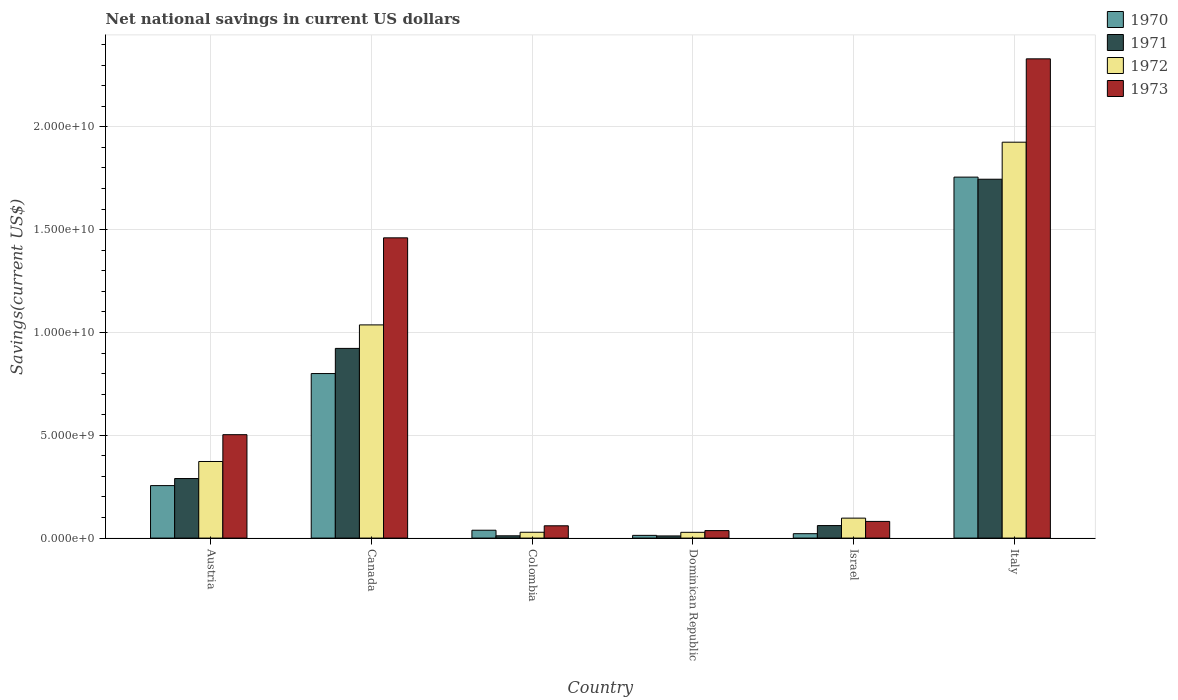Are the number of bars per tick equal to the number of legend labels?
Keep it short and to the point. Yes. How many bars are there on the 5th tick from the left?
Offer a terse response. 4. How many bars are there on the 3rd tick from the right?
Your answer should be compact. 4. What is the net national savings in 1973 in Israel?
Keep it short and to the point. 8.11e+08. Across all countries, what is the maximum net national savings in 1970?
Your answer should be compact. 1.76e+1. Across all countries, what is the minimum net national savings in 1970?
Offer a very short reply. 1.33e+08. In which country was the net national savings in 1971 minimum?
Provide a short and direct response. Dominican Republic. What is the total net national savings in 1972 in the graph?
Your answer should be very brief. 3.49e+1. What is the difference between the net national savings in 1970 in Austria and that in Italy?
Ensure brevity in your answer.  -1.50e+1. What is the difference between the net national savings in 1973 in Canada and the net national savings in 1970 in Dominican Republic?
Your answer should be very brief. 1.45e+1. What is the average net national savings in 1973 per country?
Your response must be concise. 7.45e+09. What is the difference between the net national savings of/in 1972 and net national savings of/in 1973 in Colombia?
Provide a short and direct response. -3.14e+08. In how many countries, is the net national savings in 1971 greater than 22000000000 US$?
Provide a succinct answer. 0. What is the ratio of the net national savings in 1972 in Israel to that in Italy?
Your answer should be very brief. 0.05. Is the net national savings in 1971 in Canada less than that in Dominican Republic?
Make the answer very short. No. Is the difference between the net national savings in 1972 in Colombia and Israel greater than the difference between the net national savings in 1973 in Colombia and Israel?
Offer a very short reply. No. What is the difference between the highest and the second highest net national savings in 1972?
Offer a terse response. 8.89e+09. What is the difference between the highest and the lowest net national savings in 1973?
Your response must be concise. 2.29e+1. In how many countries, is the net national savings in 1971 greater than the average net national savings in 1971 taken over all countries?
Your answer should be very brief. 2. Is it the case that in every country, the sum of the net national savings in 1971 and net national savings in 1973 is greater than the sum of net national savings in 1972 and net national savings in 1970?
Give a very brief answer. No. Is it the case that in every country, the sum of the net national savings in 1972 and net national savings in 1971 is greater than the net national savings in 1970?
Give a very brief answer. Yes. How many bars are there?
Offer a terse response. 24. Are all the bars in the graph horizontal?
Make the answer very short. No. Does the graph contain grids?
Ensure brevity in your answer.  Yes. How are the legend labels stacked?
Make the answer very short. Vertical. What is the title of the graph?
Your response must be concise. Net national savings in current US dollars. Does "2014" appear as one of the legend labels in the graph?
Provide a short and direct response. No. What is the label or title of the X-axis?
Offer a very short reply. Country. What is the label or title of the Y-axis?
Your response must be concise. Savings(current US$). What is the Savings(current US$) of 1970 in Austria?
Keep it short and to the point. 2.55e+09. What is the Savings(current US$) of 1971 in Austria?
Keep it short and to the point. 2.90e+09. What is the Savings(current US$) of 1972 in Austria?
Provide a short and direct response. 3.73e+09. What is the Savings(current US$) of 1973 in Austria?
Keep it short and to the point. 5.03e+09. What is the Savings(current US$) of 1970 in Canada?
Provide a succinct answer. 8.00e+09. What is the Savings(current US$) of 1971 in Canada?
Ensure brevity in your answer.  9.23e+09. What is the Savings(current US$) in 1972 in Canada?
Give a very brief answer. 1.04e+1. What is the Savings(current US$) in 1973 in Canada?
Provide a succinct answer. 1.46e+1. What is the Savings(current US$) of 1970 in Colombia?
Ensure brevity in your answer.  3.83e+08. What is the Savings(current US$) of 1971 in Colombia?
Your answer should be compact. 1.11e+08. What is the Savings(current US$) of 1972 in Colombia?
Your response must be concise. 2.84e+08. What is the Savings(current US$) in 1973 in Colombia?
Give a very brief answer. 5.98e+08. What is the Savings(current US$) of 1970 in Dominican Republic?
Your response must be concise. 1.33e+08. What is the Savings(current US$) of 1971 in Dominican Republic?
Offer a very short reply. 1.05e+08. What is the Savings(current US$) in 1972 in Dominican Republic?
Ensure brevity in your answer.  2.80e+08. What is the Savings(current US$) of 1973 in Dominican Republic?
Make the answer very short. 3.65e+08. What is the Savings(current US$) of 1970 in Israel?
Your response must be concise. 2.15e+08. What is the Savings(current US$) in 1971 in Israel?
Provide a short and direct response. 6.09e+08. What is the Savings(current US$) in 1972 in Israel?
Offer a very short reply. 9.71e+08. What is the Savings(current US$) in 1973 in Israel?
Give a very brief answer. 8.11e+08. What is the Savings(current US$) of 1970 in Italy?
Give a very brief answer. 1.76e+1. What is the Savings(current US$) of 1971 in Italy?
Keep it short and to the point. 1.75e+1. What is the Savings(current US$) in 1972 in Italy?
Your response must be concise. 1.93e+1. What is the Savings(current US$) in 1973 in Italy?
Make the answer very short. 2.33e+1. Across all countries, what is the maximum Savings(current US$) in 1970?
Provide a succinct answer. 1.76e+1. Across all countries, what is the maximum Savings(current US$) in 1971?
Offer a very short reply. 1.75e+1. Across all countries, what is the maximum Savings(current US$) in 1972?
Your response must be concise. 1.93e+1. Across all countries, what is the maximum Savings(current US$) of 1973?
Your response must be concise. 2.33e+1. Across all countries, what is the minimum Savings(current US$) of 1970?
Ensure brevity in your answer.  1.33e+08. Across all countries, what is the minimum Savings(current US$) in 1971?
Offer a terse response. 1.05e+08. Across all countries, what is the minimum Savings(current US$) in 1972?
Offer a very short reply. 2.80e+08. Across all countries, what is the minimum Savings(current US$) of 1973?
Offer a terse response. 3.65e+08. What is the total Savings(current US$) in 1970 in the graph?
Provide a short and direct response. 2.88e+1. What is the total Savings(current US$) of 1971 in the graph?
Offer a terse response. 3.04e+1. What is the total Savings(current US$) of 1972 in the graph?
Offer a very short reply. 3.49e+1. What is the total Savings(current US$) in 1973 in the graph?
Offer a very short reply. 4.47e+1. What is the difference between the Savings(current US$) of 1970 in Austria and that in Canada?
Provide a succinct answer. -5.45e+09. What is the difference between the Savings(current US$) in 1971 in Austria and that in Canada?
Your answer should be compact. -6.33e+09. What is the difference between the Savings(current US$) of 1972 in Austria and that in Canada?
Your answer should be compact. -6.64e+09. What is the difference between the Savings(current US$) in 1973 in Austria and that in Canada?
Your answer should be very brief. -9.57e+09. What is the difference between the Savings(current US$) in 1970 in Austria and that in Colombia?
Keep it short and to the point. 2.17e+09. What is the difference between the Savings(current US$) of 1971 in Austria and that in Colombia?
Make the answer very short. 2.78e+09. What is the difference between the Savings(current US$) of 1972 in Austria and that in Colombia?
Keep it short and to the point. 3.44e+09. What is the difference between the Savings(current US$) in 1973 in Austria and that in Colombia?
Offer a very short reply. 4.43e+09. What is the difference between the Savings(current US$) of 1970 in Austria and that in Dominican Republic?
Offer a very short reply. 2.42e+09. What is the difference between the Savings(current US$) of 1971 in Austria and that in Dominican Republic?
Provide a short and direct response. 2.79e+09. What is the difference between the Savings(current US$) of 1972 in Austria and that in Dominican Republic?
Make the answer very short. 3.44e+09. What is the difference between the Savings(current US$) in 1973 in Austria and that in Dominican Republic?
Make the answer very short. 4.66e+09. What is the difference between the Savings(current US$) of 1970 in Austria and that in Israel?
Your answer should be very brief. 2.34e+09. What is the difference between the Savings(current US$) in 1971 in Austria and that in Israel?
Make the answer very short. 2.29e+09. What is the difference between the Savings(current US$) of 1972 in Austria and that in Israel?
Ensure brevity in your answer.  2.75e+09. What is the difference between the Savings(current US$) in 1973 in Austria and that in Israel?
Make the answer very short. 4.22e+09. What is the difference between the Savings(current US$) of 1970 in Austria and that in Italy?
Your response must be concise. -1.50e+1. What is the difference between the Savings(current US$) of 1971 in Austria and that in Italy?
Keep it short and to the point. -1.46e+1. What is the difference between the Savings(current US$) of 1972 in Austria and that in Italy?
Ensure brevity in your answer.  -1.55e+1. What is the difference between the Savings(current US$) of 1973 in Austria and that in Italy?
Make the answer very short. -1.83e+1. What is the difference between the Savings(current US$) in 1970 in Canada and that in Colombia?
Offer a terse response. 7.62e+09. What is the difference between the Savings(current US$) of 1971 in Canada and that in Colombia?
Your answer should be compact. 9.11e+09. What is the difference between the Savings(current US$) of 1972 in Canada and that in Colombia?
Keep it short and to the point. 1.01e+1. What is the difference between the Savings(current US$) in 1973 in Canada and that in Colombia?
Give a very brief answer. 1.40e+1. What is the difference between the Savings(current US$) of 1970 in Canada and that in Dominican Republic?
Ensure brevity in your answer.  7.87e+09. What is the difference between the Savings(current US$) in 1971 in Canada and that in Dominican Republic?
Make the answer very short. 9.12e+09. What is the difference between the Savings(current US$) in 1972 in Canada and that in Dominican Republic?
Your answer should be compact. 1.01e+1. What is the difference between the Savings(current US$) of 1973 in Canada and that in Dominican Republic?
Provide a succinct answer. 1.42e+1. What is the difference between the Savings(current US$) of 1970 in Canada and that in Israel?
Keep it short and to the point. 7.79e+09. What is the difference between the Savings(current US$) in 1971 in Canada and that in Israel?
Offer a very short reply. 8.62e+09. What is the difference between the Savings(current US$) of 1972 in Canada and that in Israel?
Give a very brief answer. 9.40e+09. What is the difference between the Savings(current US$) of 1973 in Canada and that in Israel?
Give a very brief answer. 1.38e+1. What is the difference between the Savings(current US$) of 1970 in Canada and that in Italy?
Offer a very short reply. -9.55e+09. What is the difference between the Savings(current US$) of 1971 in Canada and that in Italy?
Provide a short and direct response. -8.23e+09. What is the difference between the Savings(current US$) in 1972 in Canada and that in Italy?
Provide a short and direct response. -8.89e+09. What is the difference between the Savings(current US$) of 1973 in Canada and that in Italy?
Make the answer very short. -8.71e+09. What is the difference between the Savings(current US$) of 1970 in Colombia and that in Dominican Republic?
Make the answer very short. 2.50e+08. What is the difference between the Savings(current US$) of 1971 in Colombia and that in Dominican Republic?
Keep it short and to the point. 6.03e+06. What is the difference between the Savings(current US$) in 1972 in Colombia and that in Dominican Republic?
Offer a very short reply. 3.48e+06. What is the difference between the Savings(current US$) of 1973 in Colombia and that in Dominican Republic?
Give a very brief answer. 2.34e+08. What is the difference between the Savings(current US$) of 1970 in Colombia and that in Israel?
Make the answer very short. 1.68e+08. What is the difference between the Savings(current US$) in 1971 in Colombia and that in Israel?
Make the answer very short. -4.97e+08. What is the difference between the Savings(current US$) in 1972 in Colombia and that in Israel?
Ensure brevity in your answer.  -6.87e+08. What is the difference between the Savings(current US$) in 1973 in Colombia and that in Israel?
Provide a short and direct response. -2.12e+08. What is the difference between the Savings(current US$) in 1970 in Colombia and that in Italy?
Offer a very short reply. -1.72e+1. What is the difference between the Savings(current US$) in 1971 in Colombia and that in Italy?
Your answer should be compact. -1.73e+1. What is the difference between the Savings(current US$) of 1972 in Colombia and that in Italy?
Provide a succinct answer. -1.90e+1. What is the difference between the Savings(current US$) in 1973 in Colombia and that in Italy?
Give a very brief answer. -2.27e+1. What is the difference between the Savings(current US$) in 1970 in Dominican Republic and that in Israel?
Provide a short and direct response. -8.19e+07. What is the difference between the Savings(current US$) in 1971 in Dominican Republic and that in Israel?
Ensure brevity in your answer.  -5.03e+08. What is the difference between the Savings(current US$) in 1972 in Dominican Republic and that in Israel?
Provide a succinct answer. -6.90e+08. What is the difference between the Savings(current US$) of 1973 in Dominican Republic and that in Israel?
Provide a succinct answer. -4.46e+08. What is the difference between the Savings(current US$) in 1970 in Dominican Republic and that in Italy?
Provide a short and direct response. -1.74e+1. What is the difference between the Savings(current US$) of 1971 in Dominican Republic and that in Italy?
Your answer should be very brief. -1.73e+1. What is the difference between the Savings(current US$) in 1972 in Dominican Republic and that in Italy?
Keep it short and to the point. -1.90e+1. What is the difference between the Savings(current US$) of 1973 in Dominican Republic and that in Italy?
Keep it short and to the point. -2.29e+1. What is the difference between the Savings(current US$) of 1970 in Israel and that in Italy?
Provide a short and direct response. -1.73e+1. What is the difference between the Savings(current US$) of 1971 in Israel and that in Italy?
Your answer should be compact. -1.68e+1. What is the difference between the Savings(current US$) of 1972 in Israel and that in Italy?
Offer a very short reply. -1.83e+1. What is the difference between the Savings(current US$) of 1973 in Israel and that in Italy?
Your response must be concise. -2.25e+1. What is the difference between the Savings(current US$) of 1970 in Austria and the Savings(current US$) of 1971 in Canada?
Offer a terse response. -6.67e+09. What is the difference between the Savings(current US$) in 1970 in Austria and the Savings(current US$) in 1972 in Canada?
Provide a short and direct response. -7.82e+09. What is the difference between the Savings(current US$) in 1970 in Austria and the Savings(current US$) in 1973 in Canada?
Make the answer very short. -1.20e+1. What is the difference between the Savings(current US$) in 1971 in Austria and the Savings(current US$) in 1972 in Canada?
Your answer should be compact. -7.47e+09. What is the difference between the Savings(current US$) of 1971 in Austria and the Savings(current US$) of 1973 in Canada?
Offer a very short reply. -1.17e+1. What is the difference between the Savings(current US$) in 1972 in Austria and the Savings(current US$) in 1973 in Canada?
Your answer should be very brief. -1.09e+1. What is the difference between the Savings(current US$) in 1970 in Austria and the Savings(current US$) in 1971 in Colombia?
Make the answer very short. 2.44e+09. What is the difference between the Savings(current US$) of 1970 in Austria and the Savings(current US$) of 1972 in Colombia?
Offer a terse response. 2.27e+09. What is the difference between the Savings(current US$) of 1970 in Austria and the Savings(current US$) of 1973 in Colombia?
Ensure brevity in your answer.  1.95e+09. What is the difference between the Savings(current US$) of 1971 in Austria and the Savings(current US$) of 1972 in Colombia?
Provide a short and direct response. 2.61e+09. What is the difference between the Savings(current US$) of 1971 in Austria and the Savings(current US$) of 1973 in Colombia?
Give a very brief answer. 2.30e+09. What is the difference between the Savings(current US$) of 1972 in Austria and the Savings(current US$) of 1973 in Colombia?
Your response must be concise. 3.13e+09. What is the difference between the Savings(current US$) in 1970 in Austria and the Savings(current US$) in 1971 in Dominican Republic?
Offer a terse response. 2.45e+09. What is the difference between the Savings(current US$) in 1970 in Austria and the Savings(current US$) in 1972 in Dominican Republic?
Make the answer very short. 2.27e+09. What is the difference between the Savings(current US$) in 1970 in Austria and the Savings(current US$) in 1973 in Dominican Republic?
Your answer should be very brief. 2.19e+09. What is the difference between the Savings(current US$) of 1971 in Austria and the Savings(current US$) of 1972 in Dominican Republic?
Your answer should be compact. 2.62e+09. What is the difference between the Savings(current US$) in 1971 in Austria and the Savings(current US$) in 1973 in Dominican Republic?
Give a very brief answer. 2.53e+09. What is the difference between the Savings(current US$) in 1972 in Austria and the Savings(current US$) in 1973 in Dominican Republic?
Offer a very short reply. 3.36e+09. What is the difference between the Savings(current US$) of 1970 in Austria and the Savings(current US$) of 1971 in Israel?
Provide a succinct answer. 1.94e+09. What is the difference between the Savings(current US$) in 1970 in Austria and the Savings(current US$) in 1972 in Israel?
Provide a short and direct response. 1.58e+09. What is the difference between the Savings(current US$) in 1970 in Austria and the Savings(current US$) in 1973 in Israel?
Your answer should be very brief. 1.74e+09. What is the difference between the Savings(current US$) in 1971 in Austria and the Savings(current US$) in 1972 in Israel?
Your response must be concise. 1.93e+09. What is the difference between the Savings(current US$) in 1971 in Austria and the Savings(current US$) in 1973 in Israel?
Keep it short and to the point. 2.09e+09. What is the difference between the Savings(current US$) in 1972 in Austria and the Savings(current US$) in 1973 in Israel?
Your response must be concise. 2.91e+09. What is the difference between the Savings(current US$) of 1970 in Austria and the Savings(current US$) of 1971 in Italy?
Offer a very short reply. -1.49e+1. What is the difference between the Savings(current US$) in 1970 in Austria and the Savings(current US$) in 1972 in Italy?
Keep it short and to the point. -1.67e+1. What is the difference between the Savings(current US$) of 1970 in Austria and the Savings(current US$) of 1973 in Italy?
Ensure brevity in your answer.  -2.08e+1. What is the difference between the Savings(current US$) in 1971 in Austria and the Savings(current US$) in 1972 in Italy?
Offer a very short reply. -1.64e+1. What is the difference between the Savings(current US$) in 1971 in Austria and the Savings(current US$) in 1973 in Italy?
Your response must be concise. -2.04e+1. What is the difference between the Savings(current US$) of 1972 in Austria and the Savings(current US$) of 1973 in Italy?
Offer a terse response. -1.96e+1. What is the difference between the Savings(current US$) of 1970 in Canada and the Savings(current US$) of 1971 in Colombia?
Offer a terse response. 7.89e+09. What is the difference between the Savings(current US$) in 1970 in Canada and the Savings(current US$) in 1972 in Colombia?
Keep it short and to the point. 7.72e+09. What is the difference between the Savings(current US$) in 1970 in Canada and the Savings(current US$) in 1973 in Colombia?
Make the answer very short. 7.40e+09. What is the difference between the Savings(current US$) of 1971 in Canada and the Savings(current US$) of 1972 in Colombia?
Offer a very short reply. 8.94e+09. What is the difference between the Savings(current US$) in 1971 in Canada and the Savings(current US$) in 1973 in Colombia?
Give a very brief answer. 8.63e+09. What is the difference between the Savings(current US$) in 1972 in Canada and the Savings(current US$) in 1973 in Colombia?
Provide a short and direct response. 9.77e+09. What is the difference between the Savings(current US$) of 1970 in Canada and the Savings(current US$) of 1971 in Dominican Republic?
Your answer should be compact. 7.90e+09. What is the difference between the Savings(current US$) of 1970 in Canada and the Savings(current US$) of 1972 in Dominican Republic?
Ensure brevity in your answer.  7.72e+09. What is the difference between the Savings(current US$) of 1970 in Canada and the Savings(current US$) of 1973 in Dominican Republic?
Keep it short and to the point. 7.64e+09. What is the difference between the Savings(current US$) of 1971 in Canada and the Savings(current US$) of 1972 in Dominican Republic?
Make the answer very short. 8.94e+09. What is the difference between the Savings(current US$) in 1971 in Canada and the Savings(current US$) in 1973 in Dominican Republic?
Give a very brief answer. 8.86e+09. What is the difference between the Savings(current US$) of 1972 in Canada and the Savings(current US$) of 1973 in Dominican Republic?
Offer a very short reply. 1.00e+1. What is the difference between the Savings(current US$) of 1970 in Canada and the Savings(current US$) of 1971 in Israel?
Ensure brevity in your answer.  7.39e+09. What is the difference between the Savings(current US$) in 1970 in Canada and the Savings(current US$) in 1972 in Israel?
Your answer should be compact. 7.03e+09. What is the difference between the Savings(current US$) of 1970 in Canada and the Savings(current US$) of 1973 in Israel?
Give a very brief answer. 7.19e+09. What is the difference between the Savings(current US$) in 1971 in Canada and the Savings(current US$) in 1972 in Israel?
Your answer should be compact. 8.25e+09. What is the difference between the Savings(current US$) of 1971 in Canada and the Savings(current US$) of 1973 in Israel?
Your answer should be very brief. 8.41e+09. What is the difference between the Savings(current US$) of 1972 in Canada and the Savings(current US$) of 1973 in Israel?
Ensure brevity in your answer.  9.56e+09. What is the difference between the Savings(current US$) in 1970 in Canada and the Savings(current US$) in 1971 in Italy?
Offer a very short reply. -9.45e+09. What is the difference between the Savings(current US$) in 1970 in Canada and the Savings(current US$) in 1972 in Italy?
Give a very brief answer. -1.13e+1. What is the difference between the Savings(current US$) in 1970 in Canada and the Savings(current US$) in 1973 in Italy?
Provide a succinct answer. -1.53e+1. What is the difference between the Savings(current US$) in 1971 in Canada and the Savings(current US$) in 1972 in Italy?
Keep it short and to the point. -1.00e+1. What is the difference between the Savings(current US$) in 1971 in Canada and the Savings(current US$) in 1973 in Italy?
Your response must be concise. -1.41e+1. What is the difference between the Savings(current US$) in 1972 in Canada and the Savings(current US$) in 1973 in Italy?
Your answer should be compact. -1.29e+1. What is the difference between the Savings(current US$) in 1970 in Colombia and the Savings(current US$) in 1971 in Dominican Republic?
Your response must be concise. 2.77e+08. What is the difference between the Savings(current US$) in 1970 in Colombia and the Savings(current US$) in 1972 in Dominican Republic?
Your response must be concise. 1.02e+08. What is the difference between the Savings(current US$) in 1970 in Colombia and the Savings(current US$) in 1973 in Dominican Republic?
Make the answer very short. 1.82e+07. What is the difference between the Savings(current US$) in 1971 in Colombia and the Savings(current US$) in 1972 in Dominican Republic?
Provide a succinct answer. -1.69e+08. What is the difference between the Savings(current US$) in 1971 in Colombia and the Savings(current US$) in 1973 in Dominican Republic?
Your answer should be very brief. -2.53e+08. What is the difference between the Savings(current US$) of 1972 in Colombia and the Savings(current US$) of 1973 in Dominican Republic?
Give a very brief answer. -8.05e+07. What is the difference between the Savings(current US$) of 1970 in Colombia and the Savings(current US$) of 1971 in Israel?
Offer a terse response. -2.26e+08. What is the difference between the Savings(current US$) in 1970 in Colombia and the Savings(current US$) in 1972 in Israel?
Offer a very short reply. -5.88e+08. What is the difference between the Savings(current US$) in 1970 in Colombia and the Savings(current US$) in 1973 in Israel?
Keep it short and to the point. -4.28e+08. What is the difference between the Savings(current US$) in 1971 in Colombia and the Savings(current US$) in 1972 in Israel?
Your answer should be compact. -8.59e+08. What is the difference between the Savings(current US$) in 1971 in Colombia and the Savings(current US$) in 1973 in Israel?
Provide a short and direct response. -6.99e+08. What is the difference between the Savings(current US$) of 1972 in Colombia and the Savings(current US$) of 1973 in Israel?
Give a very brief answer. -5.27e+08. What is the difference between the Savings(current US$) of 1970 in Colombia and the Savings(current US$) of 1971 in Italy?
Your response must be concise. -1.71e+1. What is the difference between the Savings(current US$) in 1970 in Colombia and the Savings(current US$) in 1972 in Italy?
Offer a very short reply. -1.89e+1. What is the difference between the Savings(current US$) of 1970 in Colombia and the Savings(current US$) of 1973 in Italy?
Your answer should be compact. -2.29e+1. What is the difference between the Savings(current US$) of 1971 in Colombia and the Savings(current US$) of 1972 in Italy?
Your answer should be very brief. -1.91e+1. What is the difference between the Savings(current US$) of 1971 in Colombia and the Savings(current US$) of 1973 in Italy?
Your answer should be compact. -2.32e+1. What is the difference between the Savings(current US$) in 1972 in Colombia and the Savings(current US$) in 1973 in Italy?
Your answer should be compact. -2.30e+1. What is the difference between the Savings(current US$) of 1970 in Dominican Republic and the Savings(current US$) of 1971 in Israel?
Make the answer very short. -4.76e+08. What is the difference between the Savings(current US$) of 1970 in Dominican Republic and the Savings(current US$) of 1972 in Israel?
Offer a very short reply. -8.38e+08. What is the difference between the Savings(current US$) of 1970 in Dominican Republic and the Savings(current US$) of 1973 in Israel?
Provide a short and direct response. -6.78e+08. What is the difference between the Savings(current US$) in 1971 in Dominican Republic and the Savings(current US$) in 1972 in Israel?
Offer a terse response. -8.65e+08. What is the difference between the Savings(current US$) in 1971 in Dominican Republic and the Savings(current US$) in 1973 in Israel?
Make the answer very short. -7.05e+08. What is the difference between the Savings(current US$) of 1972 in Dominican Republic and the Savings(current US$) of 1973 in Israel?
Your response must be concise. -5.30e+08. What is the difference between the Savings(current US$) in 1970 in Dominican Republic and the Savings(current US$) in 1971 in Italy?
Offer a terse response. -1.73e+1. What is the difference between the Savings(current US$) in 1970 in Dominican Republic and the Savings(current US$) in 1972 in Italy?
Offer a very short reply. -1.91e+1. What is the difference between the Savings(current US$) of 1970 in Dominican Republic and the Savings(current US$) of 1973 in Italy?
Your answer should be compact. -2.32e+1. What is the difference between the Savings(current US$) in 1971 in Dominican Republic and the Savings(current US$) in 1972 in Italy?
Ensure brevity in your answer.  -1.91e+1. What is the difference between the Savings(current US$) in 1971 in Dominican Republic and the Savings(current US$) in 1973 in Italy?
Offer a terse response. -2.32e+1. What is the difference between the Savings(current US$) in 1972 in Dominican Republic and the Savings(current US$) in 1973 in Italy?
Your response must be concise. -2.30e+1. What is the difference between the Savings(current US$) of 1970 in Israel and the Savings(current US$) of 1971 in Italy?
Provide a succinct answer. -1.72e+1. What is the difference between the Savings(current US$) of 1970 in Israel and the Savings(current US$) of 1972 in Italy?
Offer a terse response. -1.90e+1. What is the difference between the Savings(current US$) in 1970 in Israel and the Savings(current US$) in 1973 in Italy?
Make the answer very short. -2.31e+1. What is the difference between the Savings(current US$) of 1971 in Israel and the Savings(current US$) of 1972 in Italy?
Ensure brevity in your answer.  -1.86e+1. What is the difference between the Savings(current US$) of 1971 in Israel and the Savings(current US$) of 1973 in Italy?
Your answer should be compact. -2.27e+1. What is the difference between the Savings(current US$) in 1972 in Israel and the Savings(current US$) in 1973 in Italy?
Offer a terse response. -2.23e+1. What is the average Savings(current US$) of 1970 per country?
Provide a succinct answer. 4.81e+09. What is the average Savings(current US$) in 1971 per country?
Give a very brief answer. 5.07e+09. What is the average Savings(current US$) of 1972 per country?
Keep it short and to the point. 5.81e+09. What is the average Savings(current US$) of 1973 per country?
Your answer should be very brief. 7.45e+09. What is the difference between the Savings(current US$) in 1970 and Savings(current US$) in 1971 in Austria?
Provide a succinct answer. -3.44e+08. What is the difference between the Savings(current US$) of 1970 and Savings(current US$) of 1972 in Austria?
Give a very brief answer. -1.17e+09. What is the difference between the Savings(current US$) in 1970 and Savings(current US$) in 1973 in Austria?
Make the answer very short. -2.48e+09. What is the difference between the Savings(current US$) of 1971 and Savings(current US$) of 1972 in Austria?
Make the answer very short. -8.29e+08. What is the difference between the Savings(current US$) of 1971 and Savings(current US$) of 1973 in Austria?
Your answer should be compact. -2.13e+09. What is the difference between the Savings(current US$) in 1972 and Savings(current US$) in 1973 in Austria?
Provide a short and direct response. -1.30e+09. What is the difference between the Savings(current US$) in 1970 and Savings(current US$) in 1971 in Canada?
Your answer should be compact. -1.22e+09. What is the difference between the Savings(current US$) in 1970 and Savings(current US$) in 1972 in Canada?
Provide a short and direct response. -2.37e+09. What is the difference between the Savings(current US$) in 1970 and Savings(current US$) in 1973 in Canada?
Offer a very short reply. -6.60e+09. What is the difference between the Savings(current US$) of 1971 and Savings(current US$) of 1972 in Canada?
Provide a succinct answer. -1.14e+09. What is the difference between the Savings(current US$) of 1971 and Savings(current US$) of 1973 in Canada?
Keep it short and to the point. -5.38e+09. What is the difference between the Savings(current US$) of 1972 and Savings(current US$) of 1973 in Canada?
Give a very brief answer. -4.23e+09. What is the difference between the Savings(current US$) of 1970 and Savings(current US$) of 1971 in Colombia?
Ensure brevity in your answer.  2.71e+08. What is the difference between the Savings(current US$) in 1970 and Savings(current US$) in 1972 in Colombia?
Keep it short and to the point. 9.87e+07. What is the difference between the Savings(current US$) of 1970 and Savings(current US$) of 1973 in Colombia?
Offer a very short reply. -2.16e+08. What is the difference between the Savings(current US$) of 1971 and Savings(current US$) of 1972 in Colombia?
Offer a terse response. -1.73e+08. What is the difference between the Savings(current US$) of 1971 and Savings(current US$) of 1973 in Colombia?
Provide a short and direct response. -4.87e+08. What is the difference between the Savings(current US$) of 1972 and Savings(current US$) of 1973 in Colombia?
Your answer should be compact. -3.14e+08. What is the difference between the Savings(current US$) of 1970 and Savings(current US$) of 1971 in Dominican Republic?
Make the answer very short. 2.74e+07. What is the difference between the Savings(current US$) in 1970 and Savings(current US$) in 1972 in Dominican Republic?
Your answer should be very brief. -1.48e+08. What is the difference between the Savings(current US$) in 1970 and Savings(current US$) in 1973 in Dominican Republic?
Your answer should be compact. -2.32e+08. What is the difference between the Savings(current US$) in 1971 and Savings(current US$) in 1972 in Dominican Republic?
Provide a short and direct response. -1.75e+08. What is the difference between the Savings(current US$) of 1971 and Savings(current US$) of 1973 in Dominican Republic?
Give a very brief answer. -2.59e+08. What is the difference between the Savings(current US$) of 1972 and Savings(current US$) of 1973 in Dominican Republic?
Offer a very short reply. -8.40e+07. What is the difference between the Savings(current US$) of 1970 and Savings(current US$) of 1971 in Israel?
Keep it short and to the point. -3.94e+08. What is the difference between the Savings(current US$) in 1970 and Savings(current US$) in 1972 in Israel?
Give a very brief answer. -7.56e+08. What is the difference between the Savings(current US$) of 1970 and Savings(current US$) of 1973 in Israel?
Keep it short and to the point. -5.96e+08. What is the difference between the Savings(current US$) of 1971 and Savings(current US$) of 1972 in Israel?
Your answer should be compact. -3.62e+08. What is the difference between the Savings(current US$) in 1971 and Savings(current US$) in 1973 in Israel?
Your answer should be compact. -2.02e+08. What is the difference between the Savings(current US$) in 1972 and Savings(current US$) in 1973 in Israel?
Offer a terse response. 1.60e+08. What is the difference between the Savings(current US$) in 1970 and Savings(current US$) in 1971 in Italy?
Give a very brief answer. 1.03e+08. What is the difference between the Savings(current US$) in 1970 and Savings(current US$) in 1972 in Italy?
Give a very brief answer. -1.70e+09. What is the difference between the Savings(current US$) of 1970 and Savings(current US$) of 1973 in Italy?
Make the answer very short. -5.75e+09. What is the difference between the Savings(current US$) of 1971 and Savings(current US$) of 1972 in Italy?
Offer a terse response. -1.80e+09. What is the difference between the Savings(current US$) of 1971 and Savings(current US$) of 1973 in Italy?
Make the answer very short. -5.86e+09. What is the difference between the Savings(current US$) in 1972 and Savings(current US$) in 1973 in Italy?
Offer a very short reply. -4.05e+09. What is the ratio of the Savings(current US$) of 1970 in Austria to that in Canada?
Your response must be concise. 0.32. What is the ratio of the Savings(current US$) of 1971 in Austria to that in Canada?
Ensure brevity in your answer.  0.31. What is the ratio of the Savings(current US$) of 1972 in Austria to that in Canada?
Offer a very short reply. 0.36. What is the ratio of the Savings(current US$) of 1973 in Austria to that in Canada?
Offer a terse response. 0.34. What is the ratio of the Savings(current US$) in 1970 in Austria to that in Colombia?
Your response must be concise. 6.67. What is the ratio of the Savings(current US$) of 1971 in Austria to that in Colombia?
Provide a succinct answer. 25.99. What is the ratio of the Savings(current US$) of 1972 in Austria to that in Colombia?
Offer a terse response. 13.12. What is the ratio of the Savings(current US$) in 1973 in Austria to that in Colombia?
Provide a short and direct response. 8.4. What is the ratio of the Savings(current US$) of 1970 in Austria to that in Dominican Republic?
Make the answer very short. 19.23. What is the ratio of the Savings(current US$) of 1971 in Austria to that in Dominican Republic?
Offer a very short reply. 27.48. What is the ratio of the Savings(current US$) in 1972 in Austria to that in Dominican Republic?
Provide a short and direct response. 13.28. What is the ratio of the Savings(current US$) in 1973 in Austria to that in Dominican Republic?
Offer a very short reply. 13.8. What is the ratio of the Savings(current US$) in 1970 in Austria to that in Israel?
Offer a terse response. 11.89. What is the ratio of the Savings(current US$) of 1971 in Austria to that in Israel?
Make the answer very short. 4.76. What is the ratio of the Savings(current US$) in 1972 in Austria to that in Israel?
Your response must be concise. 3.84. What is the ratio of the Savings(current US$) of 1973 in Austria to that in Israel?
Make the answer very short. 6.2. What is the ratio of the Savings(current US$) of 1970 in Austria to that in Italy?
Your answer should be very brief. 0.15. What is the ratio of the Savings(current US$) of 1971 in Austria to that in Italy?
Ensure brevity in your answer.  0.17. What is the ratio of the Savings(current US$) of 1972 in Austria to that in Italy?
Give a very brief answer. 0.19. What is the ratio of the Savings(current US$) of 1973 in Austria to that in Italy?
Provide a short and direct response. 0.22. What is the ratio of the Savings(current US$) of 1970 in Canada to that in Colombia?
Ensure brevity in your answer.  20.91. What is the ratio of the Savings(current US$) of 1971 in Canada to that in Colombia?
Your answer should be very brief. 82.79. What is the ratio of the Savings(current US$) in 1972 in Canada to that in Colombia?
Provide a short and direct response. 36.51. What is the ratio of the Savings(current US$) of 1973 in Canada to that in Colombia?
Give a very brief answer. 24.4. What is the ratio of the Savings(current US$) in 1970 in Canada to that in Dominican Republic?
Ensure brevity in your answer.  60.27. What is the ratio of the Savings(current US$) of 1971 in Canada to that in Dominican Republic?
Provide a short and direct response. 87.52. What is the ratio of the Savings(current US$) in 1972 in Canada to that in Dominican Republic?
Offer a terse response. 36.96. What is the ratio of the Savings(current US$) of 1973 in Canada to that in Dominican Republic?
Ensure brevity in your answer.  40.06. What is the ratio of the Savings(current US$) in 1970 in Canada to that in Israel?
Provide a succinct answer. 37.28. What is the ratio of the Savings(current US$) of 1971 in Canada to that in Israel?
Make the answer very short. 15.16. What is the ratio of the Savings(current US$) in 1972 in Canada to that in Israel?
Give a very brief answer. 10.68. What is the ratio of the Savings(current US$) in 1973 in Canada to that in Israel?
Your answer should be compact. 18.01. What is the ratio of the Savings(current US$) in 1970 in Canada to that in Italy?
Offer a very short reply. 0.46. What is the ratio of the Savings(current US$) in 1971 in Canada to that in Italy?
Provide a short and direct response. 0.53. What is the ratio of the Savings(current US$) in 1972 in Canada to that in Italy?
Offer a very short reply. 0.54. What is the ratio of the Savings(current US$) of 1973 in Canada to that in Italy?
Your answer should be compact. 0.63. What is the ratio of the Savings(current US$) of 1970 in Colombia to that in Dominican Republic?
Offer a very short reply. 2.88. What is the ratio of the Savings(current US$) in 1971 in Colombia to that in Dominican Republic?
Give a very brief answer. 1.06. What is the ratio of the Savings(current US$) in 1972 in Colombia to that in Dominican Republic?
Give a very brief answer. 1.01. What is the ratio of the Savings(current US$) of 1973 in Colombia to that in Dominican Republic?
Offer a very short reply. 1.64. What is the ratio of the Savings(current US$) of 1970 in Colombia to that in Israel?
Offer a terse response. 1.78. What is the ratio of the Savings(current US$) in 1971 in Colombia to that in Israel?
Your answer should be very brief. 0.18. What is the ratio of the Savings(current US$) of 1972 in Colombia to that in Israel?
Your answer should be compact. 0.29. What is the ratio of the Savings(current US$) of 1973 in Colombia to that in Israel?
Your answer should be compact. 0.74. What is the ratio of the Savings(current US$) of 1970 in Colombia to that in Italy?
Keep it short and to the point. 0.02. What is the ratio of the Savings(current US$) in 1971 in Colombia to that in Italy?
Your response must be concise. 0.01. What is the ratio of the Savings(current US$) of 1972 in Colombia to that in Italy?
Your response must be concise. 0.01. What is the ratio of the Savings(current US$) in 1973 in Colombia to that in Italy?
Give a very brief answer. 0.03. What is the ratio of the Savings(current US$) of 1970 in Dominican Republic to that in Israel?
Provide a short and direct response. 0.62. What is the ratio of the Savings(current US$) of 1971 in Dominican Republic to that in Israel?
Keep it short and to the point. 0.17. What is the ratio of the Savings(current US$) in 1972 in Dominican Republic to that in Israel?
Provide a short and direct response. 0.29. What is the ratio of the Savings(current US$) in 1973 in Dominican Republic to that in Israel?
Provide a short and direct response. 0.45. What is the ratio of the Savings(current US$) in 1970 in Dominican Republic to that in Italy?
Give a very brief answer. 0.01. What is the ratio of the Savings(current US$) in 1971 in Dominican Republic to that in Italy?
Offer a terse response. 0.01. What is the ratio of the Savings(current US$) in 1972 in Dominican Republic to that in Italy?
Provide a short and direct response. 0.01. What is the ratio of the Savings(current US$) in 1973 in Dominican Republic to that in Italy?
Provide a succinct answer. 0.02. What is the ratio of the Savings(current US$) of 1970 in Israel to that in Italy?
Provide a short and direct response. 0.01. What is the ratio of the Savings(current US$) in 1971 in Israel to that in Italy?
Your response must be concise. 0.03. What is the ratio of the Savings(current US$) in 1972 in Israel to that in Italy?
Your response must be concise. 0.05. What is the ratio of the Savings(current US$) of 1973 in Israel to that in Italy?
Make the answer very short. 0.03. What is the difference between the highest and the second highest Savings(current US$) of 1970?
Your answer should be compact. 9.55e+09. What is the difference between the highest and the second highest Savings(current US$) of 1971?
Ensure brevity in your answer.  8.23e+09. What is the difference between the highest and the second highest Savings(current US$) of 1972?
Provide a succinct answer. 8.89e+09. What is the difference between the highest and the second highest Savings(current US$) in 1973?
Your response must be concise. 8.71e+09. What is the difference between the highest and the lowest Savings(current US$) of 1970?
Provide a short and direct response. 1.74e+1. What is the difference between the highest and the lowest Savings(current US$) in 1971?
Provide a short and direct response. 1.73e+1. What is the difference between the highest and the lowest Savings(current US$) in 1972?
Offer a terse response. 1.90e+1. What is the difference between the highest and the lowest Savings(current US$) in 1973?
Offer a very short reply. 2.29e+1. 